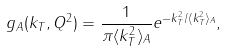<formula> <loc_0><loc_0><loc_500><loc_500>g _ { A } ( k _ { T } , Q ^ { 2 } ) = \frac { 1 } { \pi \langle k ^ { 2 } _ { T } \rangle _ { A } } e ^ { - k ^ { 2 } _ { T } / \langle k ^ { 2 } _ { T } \rangle _ { A } } ,</formula> 